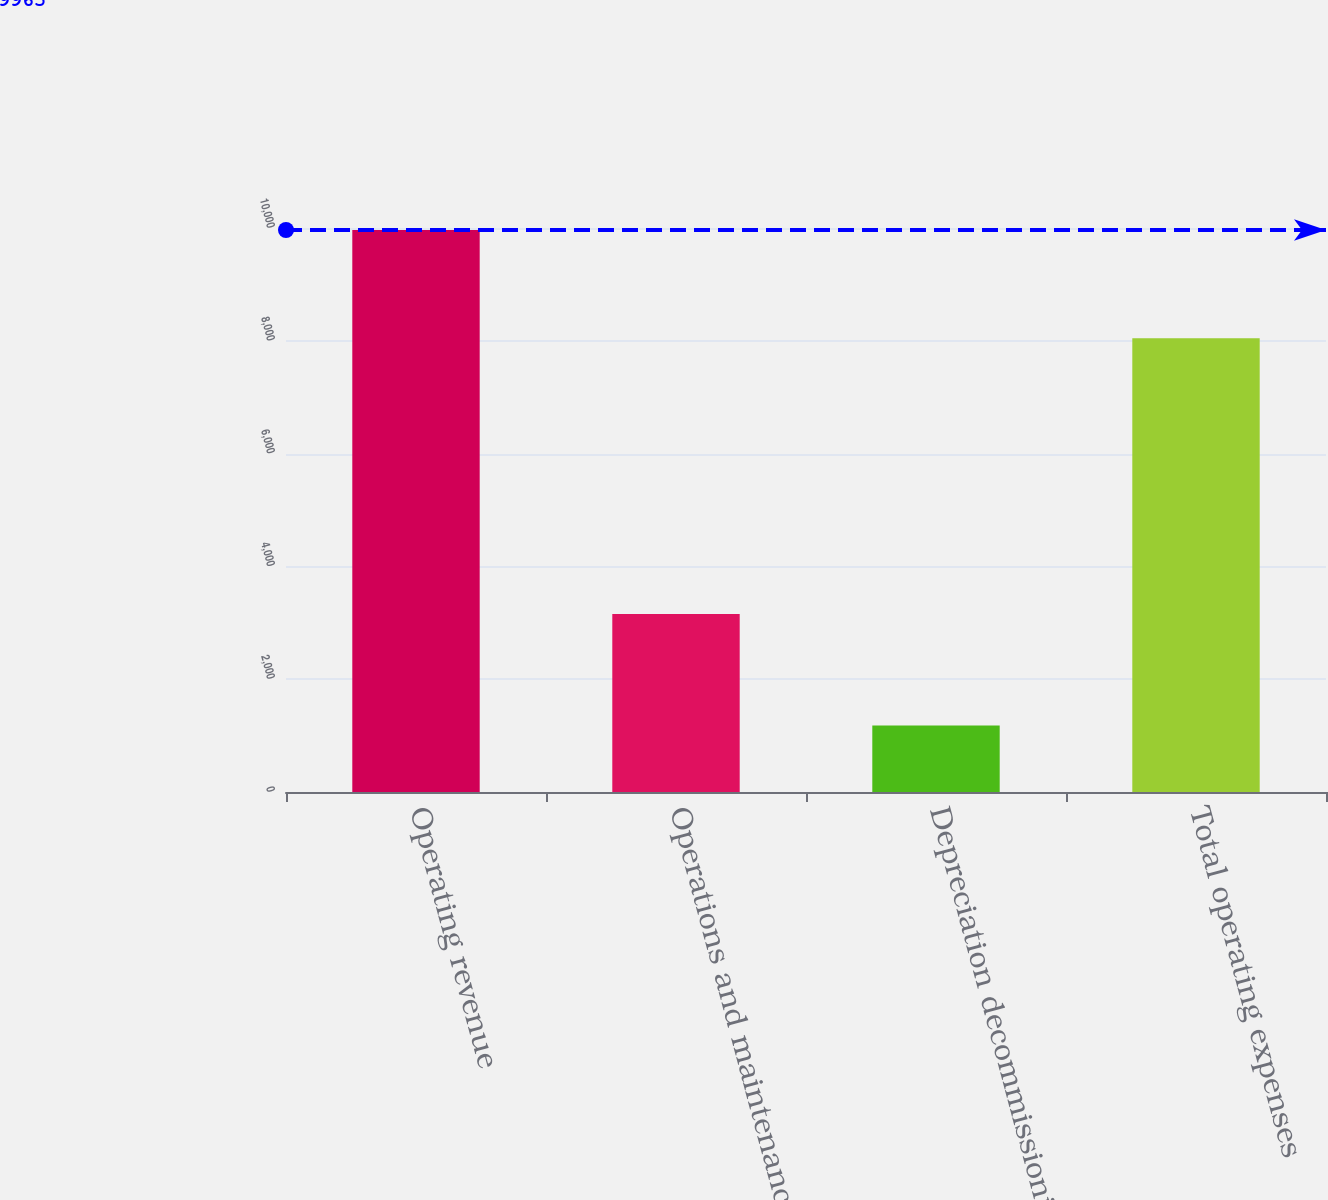Convert chart. <chart><loc_0><loc_0><loc_500><loc_500><bar_chart><fcel>Operating revenue<fcel>Operations and maintenance<fcel>Depreciation decommissioning<fcel>Total operating expenses<nl><fcel>9965<fcel>3154<fcel>1178<fcel>8047<nl></chart> 